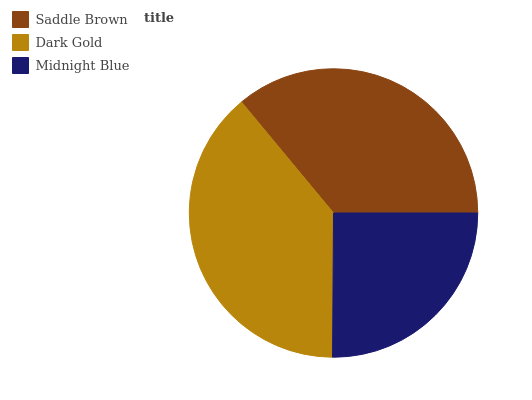Is Midnight Blue the minimum?
Answer yes or no. Yes. Is Dark Gold the maximum?
Answer yes or no. Yes. Is Dark Gold the minimum?
Answer yes or no. No. Is Midnight Blue the maximum?
Answer yes or no. No. Is Dark Gold greater than Midnight Blue?
Answer yes or no. Yes. Is Midnight Blue less than Dark Gold?
Answer yes or no. Yes. Is Midnight Blue greater than Dark Gold?
Answer yes or no. No. Is Dark Gold less than Midnight Blue?
Answer yes or no. No. Is Saddle Brown the high median?
Answer yes or no. Yes. Is Saddle Brown the low median?
Answer yes or no. Yes. Is Dark Gold the high median?
Answer yes or no. No. Is Dark Gold the low median?
Answer yes or no. No. 